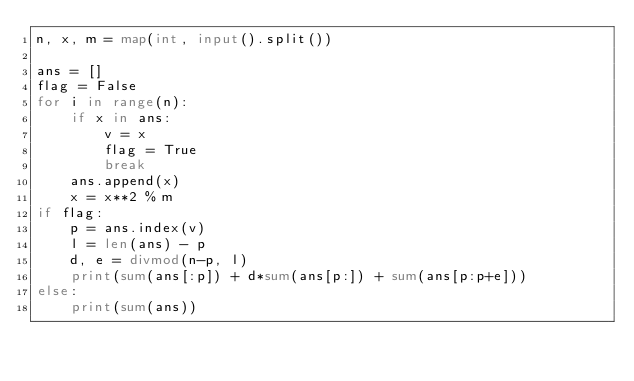<code> <loc_0><loc_0><loc_500><loc_500><_Python_>n, x, m = map(int, input().split())

ans = []
flag = False
for i in range(n):
    if x in ans:
        v = x
        flag = True
        break
    ans.append(x)
    x = x**2 % m
if flag:
    p = ans.index(v)
    l = len(ans) - p
    d, e = divmod(n-p, l)
    print(sum(ans[:p]) + d*sum(ans[p:]) + sum(ans[p:p+e]))
else:
    print(sum(ans))
</code> 